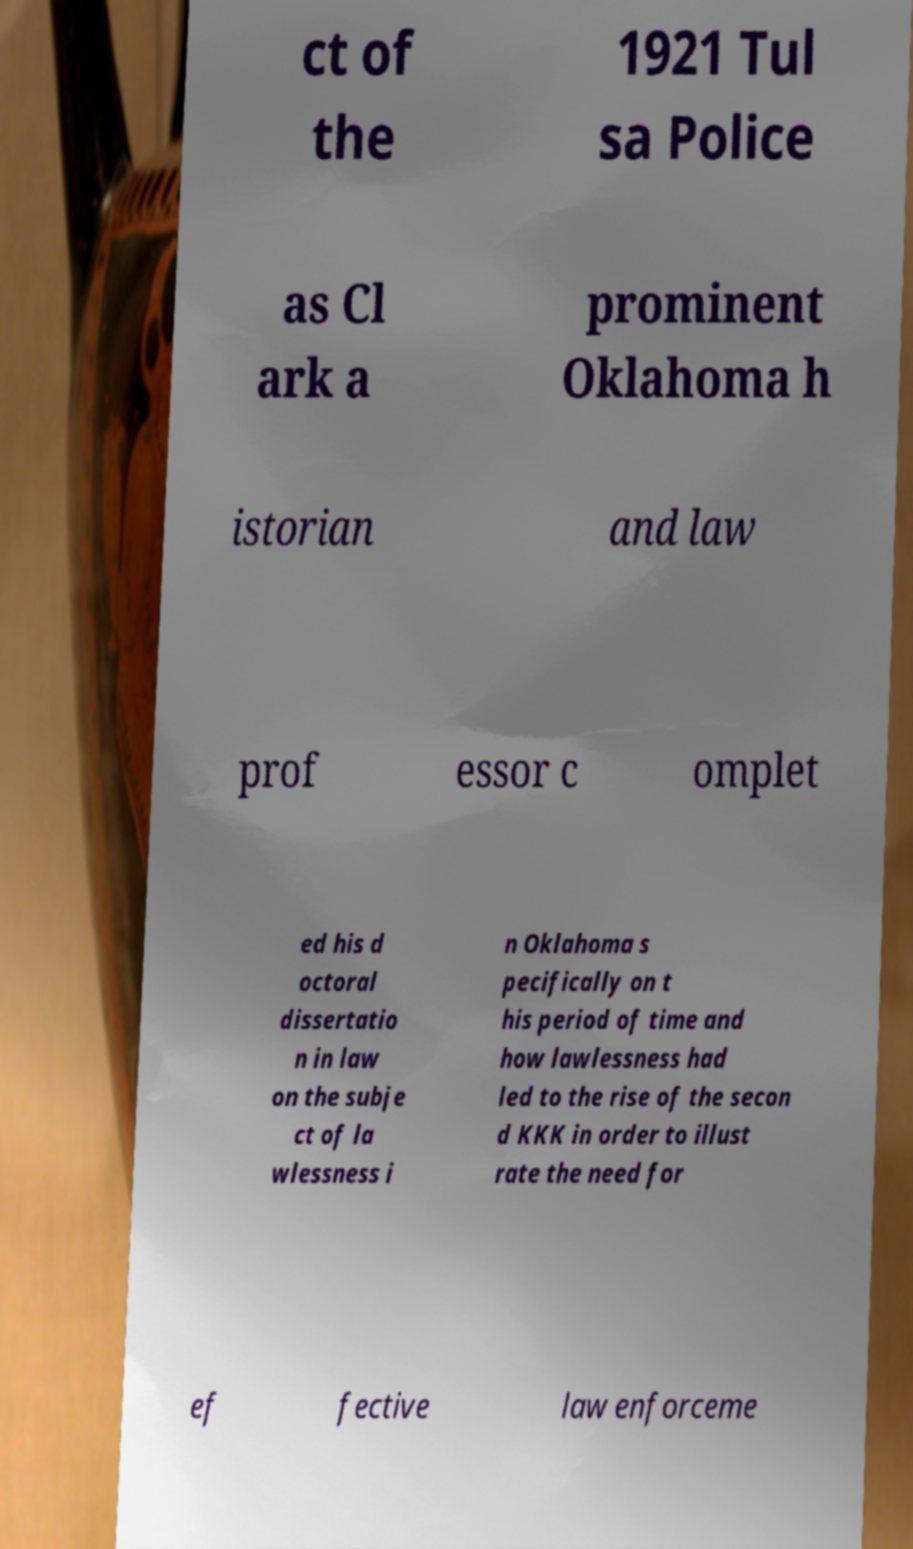Could you extract and type out the text from this image? ct of the 1921 Tul sa Police as Cl ark a prominent Oklahoma h istorian and law prof essor c omplet ed his d octoral dissertatio n in law on the subje ct of la wlessness i n Oklahoma s pecifically on t his period of time and how lawlessness had led to the rise of the secon d KKK in order to illust rate the need for ef fective law enforceme 